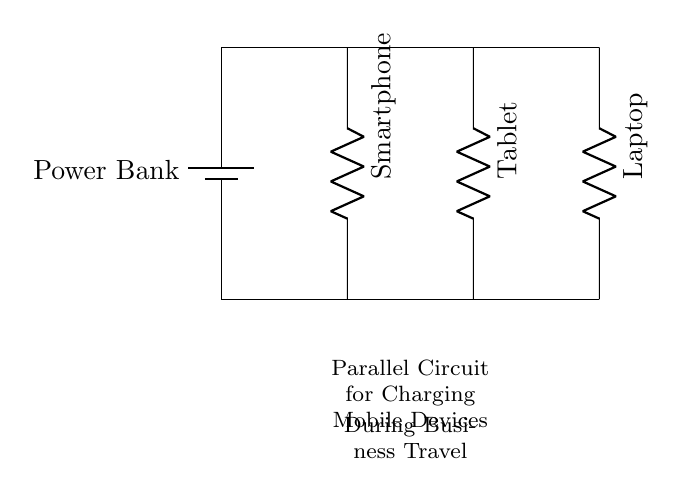What type of circuit is represented? The circuit is a parallel circuit, which allows multiple devices to be connected and charged simultaneously. Each device operates independently, which is characteristic of parallel circuits.
Answer: Parallel How many devices are connected in this circuit? There are three devices connected: a smartphone, a tablet, and a laptop. Each device is represented by a resistor symbol in the diagram.
Answer: Three What is the main power source? The main power source in the circuit is indicated by the battery symbol, labeled as "Power Bank." This provides the electrical energy to charge the devices.
Answer: Power Bank What do the lines connecting the devices represent? The lines connecting the devices represent the electrical connections, allowing current to flow from the power source to each device independently. This structure is typical in a parallel configuration.
Answer: Electrical connections If the power bank has a voltage of 5 volts, what is the voltage across each device? In a parallel circuit, the voltage across each device is equal to the voltage of the power source. Since the power bank provides 5 volts, each device receives the same voltage.
Answer: 5 volts How does the current distribute among the devices? The current in a parallel circuit is divided among the devices connected. Each device draws the amount of current it requires based on its resistance, resulting in different current values for each device but maintaining the same voltage.
Answer: Divided 